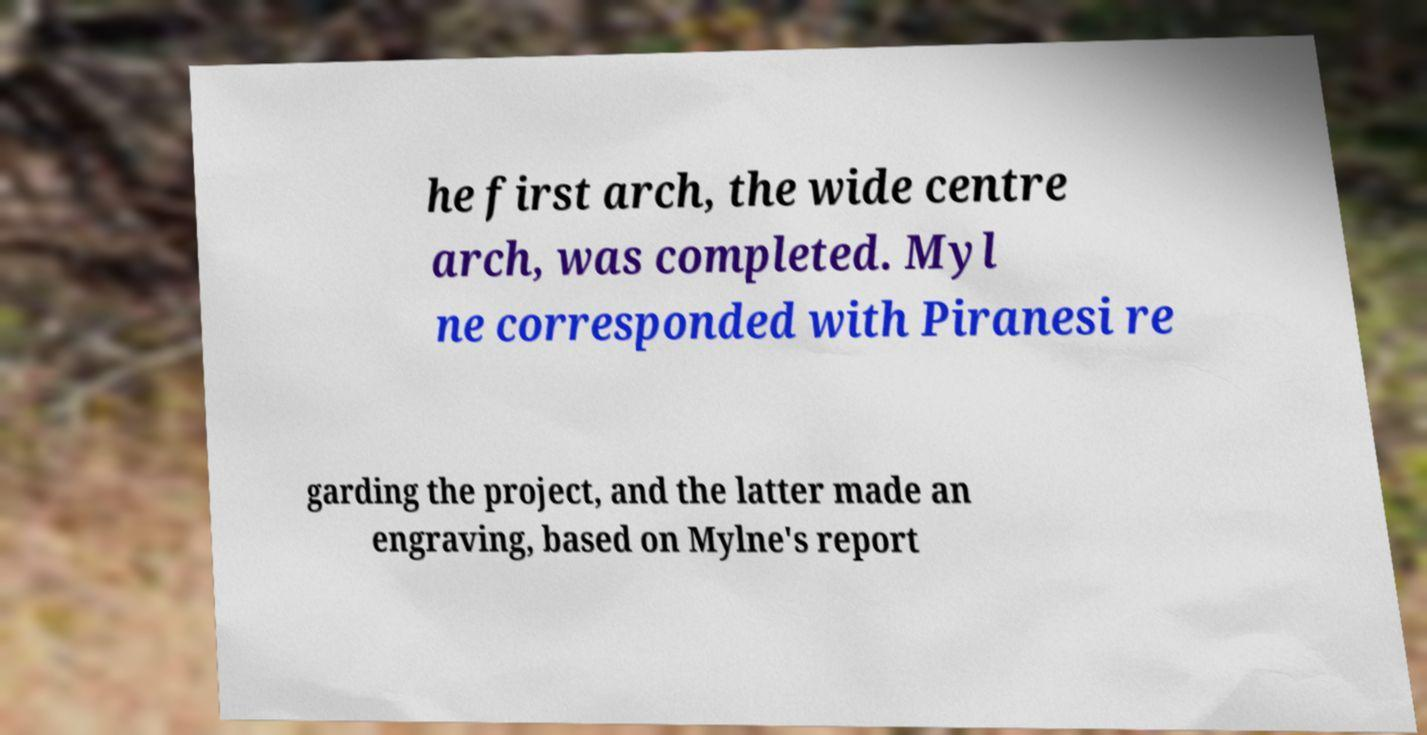Could you assist in decoding the text presented in this image and type it out clearly? he first arch, the wide centre arch, was completed. Myl ne corresponded with Piranesi re garding the project, and the latter made an engraving, based on Mylne's report 